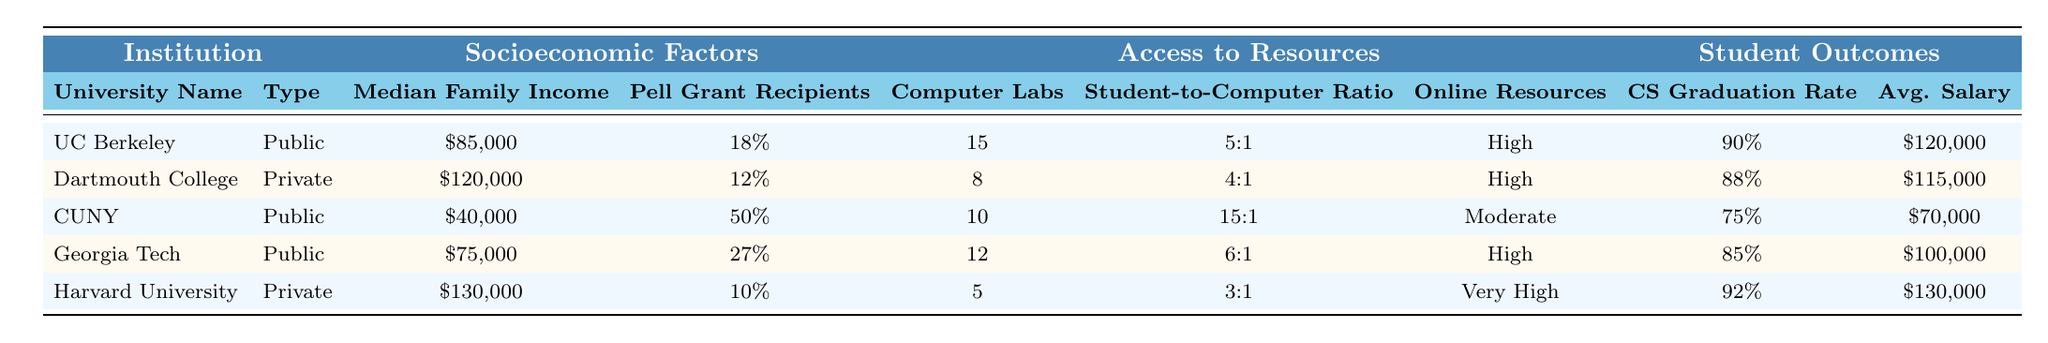What is the median family income at the University of California, Berkeley? The table lists the median family income for the University of California, Berkeley as $85,000.
Answer: $85,000 Which institution has the highest percentage of Pell Grant recipients? According to the table, City University of New York (CUNY) has the highest percentage of Pell Grant recipients at 50%.
Answer: 50% What is the average salary after graduation for students at Dartmouth College? The table indicates that the average salary after graduation for Dartmouth College graduates is $115,000.
Answer: $115,000 How many computer labs are available at Georgia Institute of Technology? The table shows that Georgia Institute of Technology has 12 computer labs available.
Answer: 12 Is the availability of online resources at Harvard University rated as "Very High"? The table confirms that the availability of online resources at Harvard University is indeed rated as "Very High."
Answer: Yes What is the average student-to-computer ratio across the five institutions? The student-to-computer ratios are 5:1, 4:1, 15:1, 6:1, and 3:1. To find the average, we convert these ratios to numeric values (1/5, 1/4, 1/15, 1/6, 1/3), sum them up, and divide by 5. The total is 0.2 + 0.25 + 0.0667 + 0.1667 + 0.3333 = 1.0333. The average ratio is approximately 1.0333 / 5 = 0.2067, which converts back to approximately 1:4.84 or about 1:5.
Answer: 1:5 What is the difference in CS graduation rate between the highest and lowest performing institutions? The highest CS graduation rate is 90% for UC Berkeley and the lowest is 75% for CUNY. The difference is 90% - 75% = 15%.
Answer: 15% Which institution has both the highest median family income and the highest average salary after graduation? Harvard University ranks highest in both median family income ($130,000) and average salary after graduation ($130,000), per the data in the table.
Answer: Harvard University How does the average student-to-computer ratio at CUNY compare to that at Harvard? CUNY has a ratio of 15:1, while Harvard has a ratio of 3:1. This indicates that CUNY has a worse (larger) student-to-computer ratio compared to Harvard, which is better (smaller). Thus, CUNY's ratio is significantly higher.
Answer: CUNY's ratio is worse than Harvard's What is the relationship between the percentage of Pell Grant recipients and CS graduation rates among public institutions? For public institutions, UC Berkeley has 18% Pell Grant recipients and a CS graduation rate of 90%, Georgia Tech has 27% and 85%, and CUNY has 50% with 75%. This indicates that as the percentage of Pell Grant recipients increases, the graduation rate tends to decrease among these institutions. This trend suggests socioeconomic factors might impact education outcomes.
Answer: Higher Pell Grant percentage correlates with lower graduation rates 